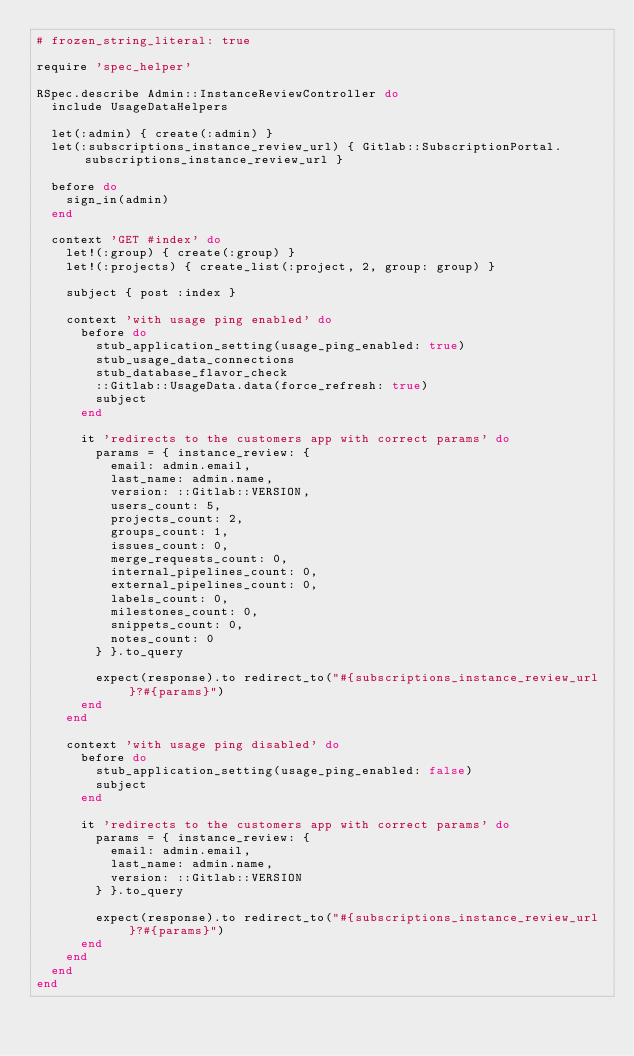<code> <loc_0><loc_0><loc_500><loc_500><_Ruby_># frozen_string_literal: true

require 'spec_helper'

RSpec.describe Admin::InstanceReviewController do
  include UsageDataHelpers

  let(:admin) { create(:admin) }
  let(:subscriptions_instance_review_url) { Gitlab::SubscriptionPortal.subscriptions_instance_review_url }

  before do
    sign_in(admin)
  end

  context 'GET #index' do
    let!(:group) { create(:group) }
    let!(:projects) { create_list(:project, 2, group: group) }

    subject { post :index }

    context 'with usage ping enabled' do
      before do
        stub_application_setting(usage_ping_enabled: true)
        stub_usage_data_connections
        stub_database_flavor_check
        ::Gitlab::UsageData.data(force_refresh: true)
        subject
      end

      it 'redirects to the customers app with correct params' do
        params = { instance_review: {
          email: admin.email,
          last_name: admin.name,
          version: ::Gitlab::VERSION,
          users_count: 5,
          projects_count: 2,
          groups_count: 1,
          issues_count: 0,
          merge_requests_count: 0,
          internal_pipelines_count: 0,
          external_pipelines_count: 0,
          labels_count: 0,
          milestones_count: 0,
          snippets_count: 0,
          notes_count: 0
        } }.to_query

        expect(response).to redirect_to("#{subscriptions_instance_review_url}?#{params}")
      end
    end

    context 'with usage ping disabled' do
      before do
        stub_application_setting(usage_ping_enabled: false)
        subject
      end

      it 'redirects to the customers app with correct params' do
        params = { instance_review: {
          email: admin.email,
          last_name: admin.name,
          version: ::Gitlab::VERSION
        } }.to_query

        expect(response).to redirect_to("#{subscriptions_instance_review_url}?#{params}")
      end
    end
  end
end
</code> 